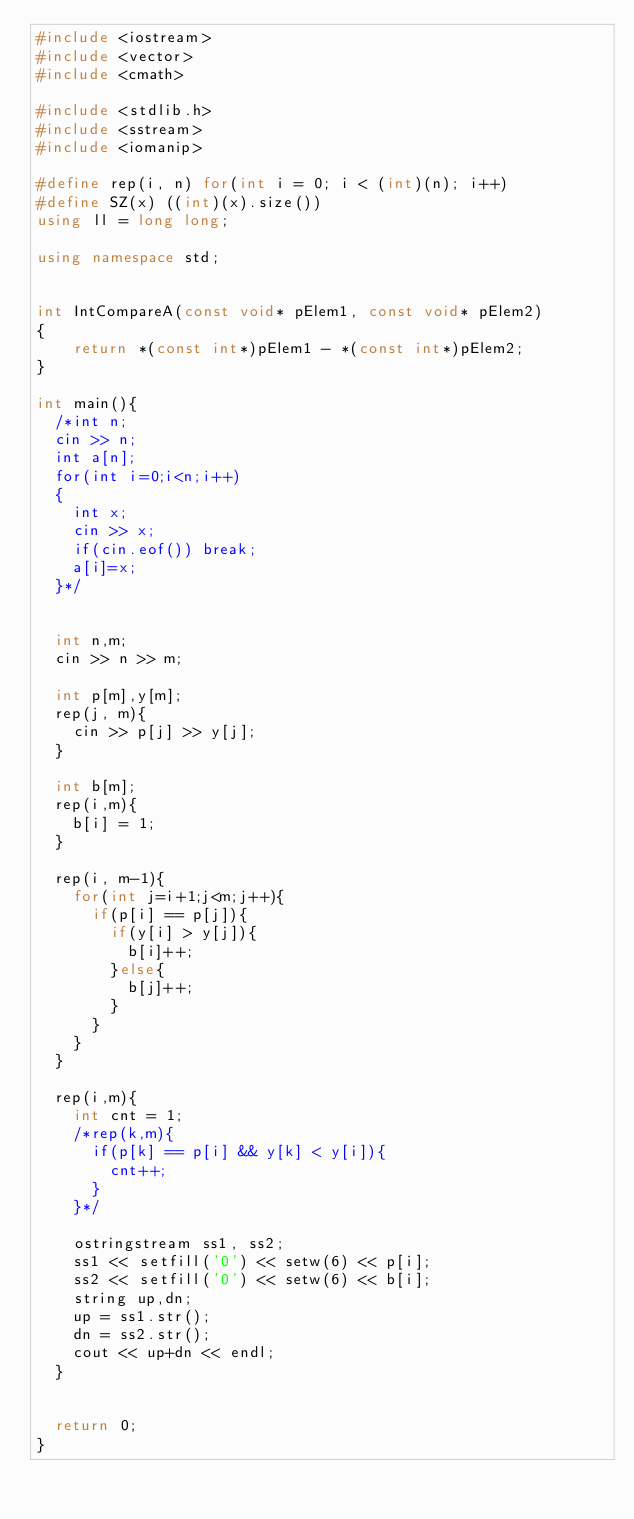Convert code to text. <code><loc_0><loc_0><loc_500><loc_500><_C++_>#include <iostream>
#include <vector>
#include <cmath>

#include <stdlib.h>
#include <sstream>
#include <iomanip>

#define rep(i, n) for(int i = 0; i < (int)(n); i++)
#define SZ(x) ((int)(x).size())
using ll = long long;

using namespace std;


int IntCompareA(const void* pElem1, const void* pElem2)
{
    return *(const int*)pElem1 - *(const int*)pElem2;
}

int main(){
	/*int n;
	cin >> n;
	int a[n];
	for(int i=0;i<n;i++)
	{
		int x;
		cin >> x;
		if(cin.eof())	break;	
		a[i]=x;
	}*/
	
	
	int n,m;
	cin >> n >> m;
	
	int p[m],y[m];
	rep(j, m){
		cin >> p[j] >> y[j];
	}
	
	int b[m];
	rep(i,m){
		b[i] = 1;
	}
	
	rep(i, m-1){
		for(int j=i+1;j<m;j++){
			if(p[i] == p[j]){
				if(y[i] > y[j]){
					b[i]++;
				}else{
					b[j]++;
				}
			}
		}
	}
	
	rep(i,m){
		int cnt = 1;
		/*rep(k,m){
			if(p[k] == p[i] && y[k] < y[i]){
				cnt++;
			}
		}*/
		
		ostringstream ss1, ss2;
		ss1 << setfill('0') << setw(6) << p[i];
		ss2 << setfill('0') << setw(6) << b[i];
		string up,dn;
		up = ss1.str();
		dn = ss2.str();
		cout << up+dn << endl;
	}
	
	
	return 0;
}
</code> 